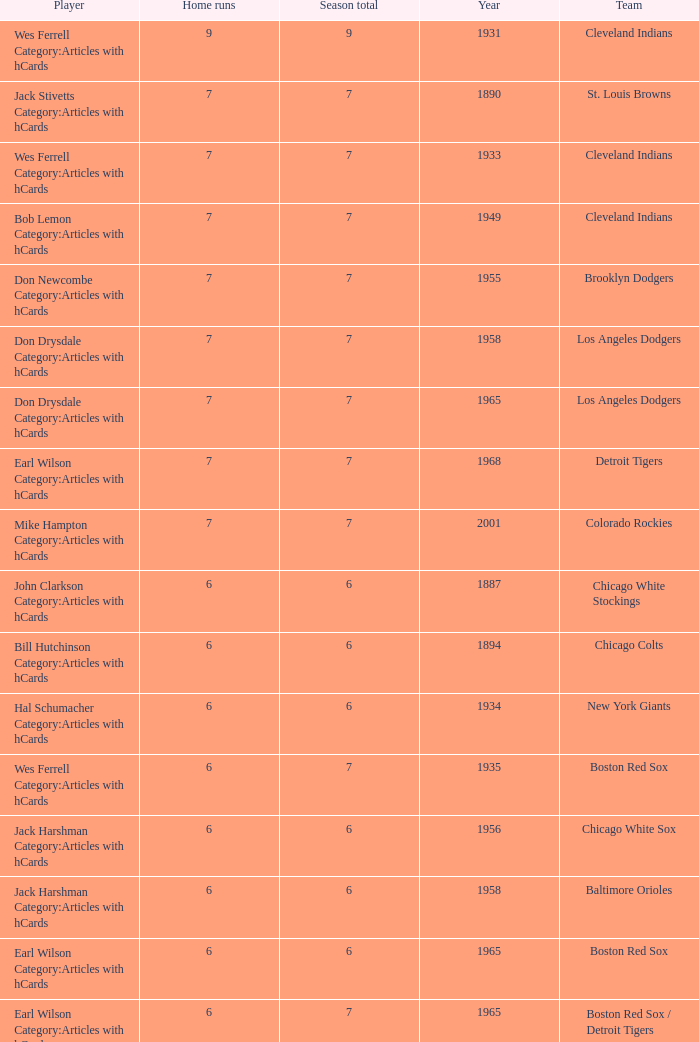Inform me of the most home runs for cleveland indians prior to 193 None. 